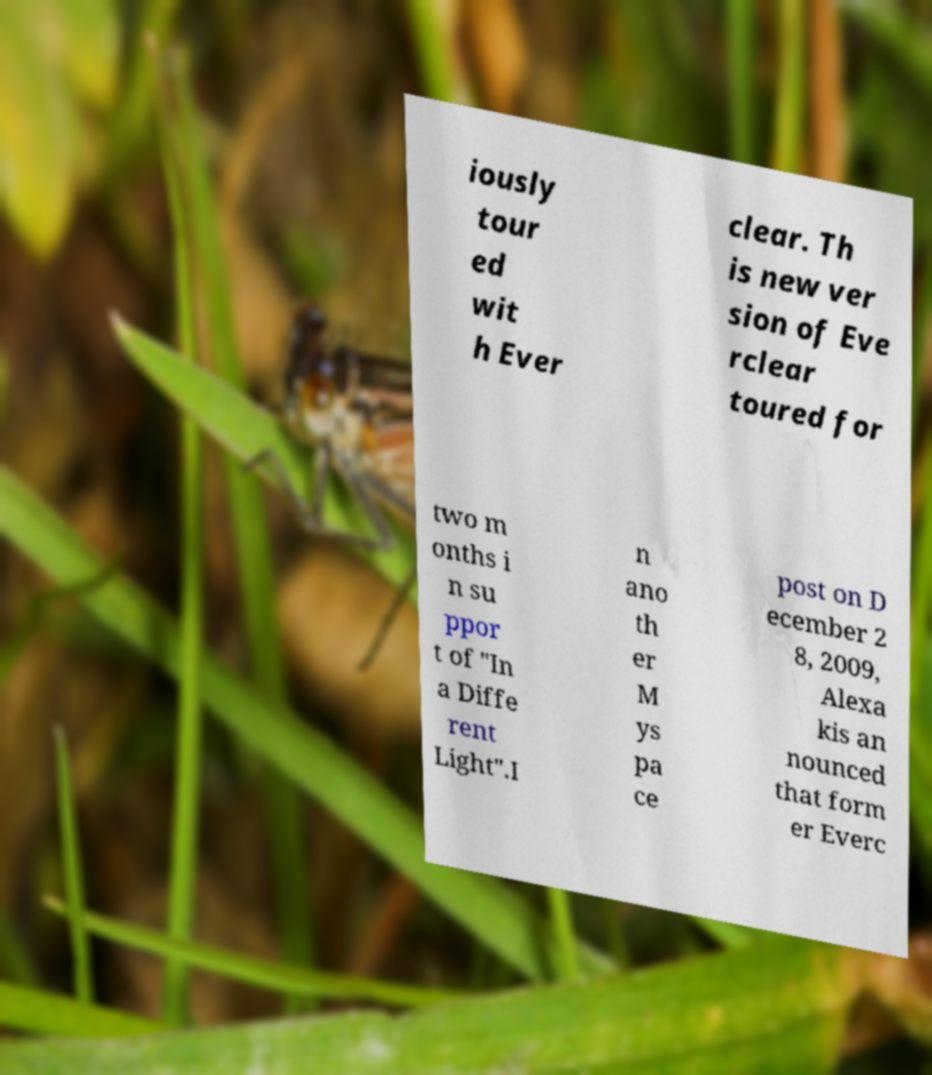What messages or text are displayed in this image? I need them in a readable, typed format. iously tour ed wit h Ever clear. Th is new ver sion of Eve rclear toured for two m onths i n su ppor t of "In a Diffe rent Light".I n ano th er M ys pa ce post on D ecember 2 8, 2009, Alexa kis an nounced that form er Everc 